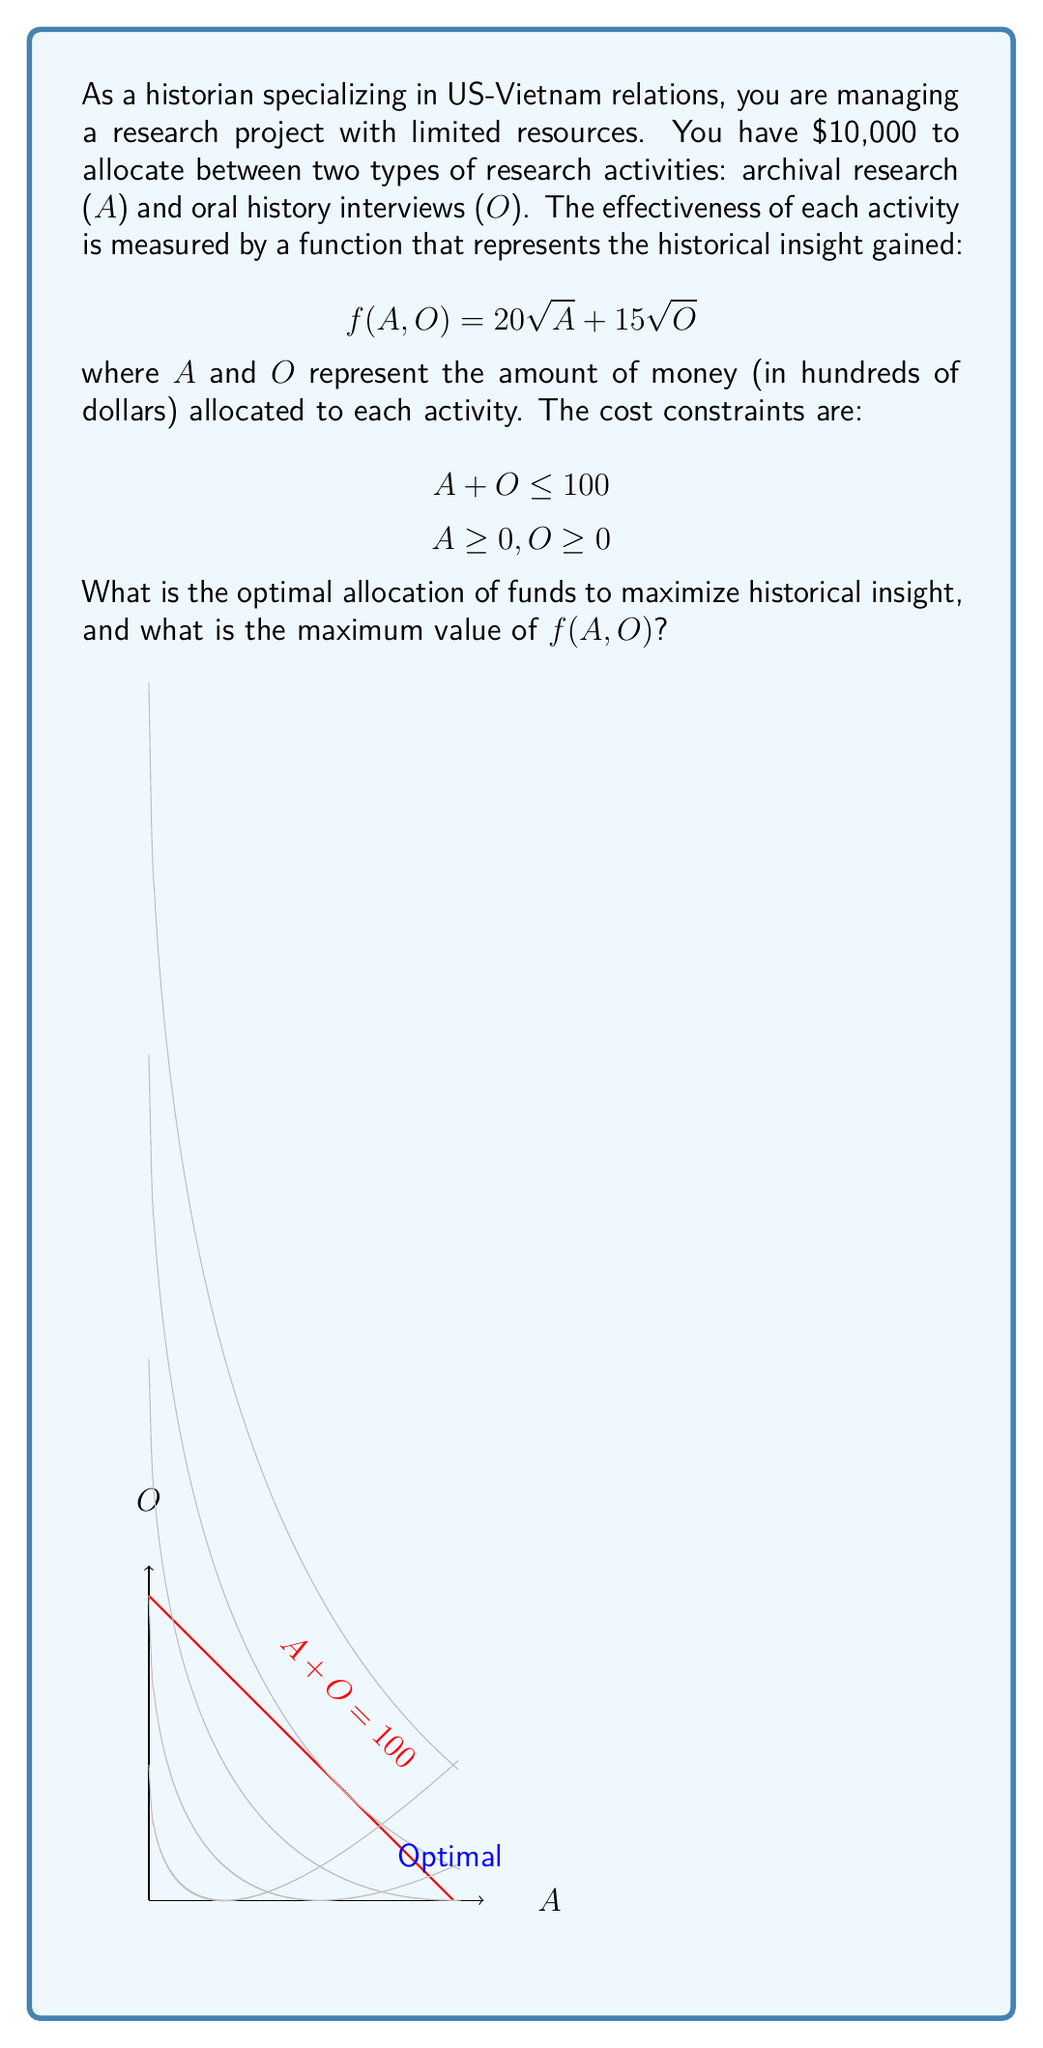Provide a solution to this math problem. To solve this optimization problem, we'll use the method of Lagrange multipliers:

1) Let's define the Lagrangian function:
   $$L(A, O, \lambda) = 20\sqrt{A} + 15\sqrt{O} + \lambda(100 - A - O)$$

2) We find the partial derivatives and set them to zero:
   $$\frac{\partial L}{\partial A} = \frac{10}{\sqrt{A}} - \lambda = 0$$
   $$\frac{\partial L}{\partial O} = \frac{7.5}{\sqrt{O}} - \lambda = 0$$
   $$\frac{\partial L}{\partial \lambda} = 100 - A - O = 0$$

3) From the first two equations:
   $$\frac{10}{\sqrt{A}} = \frac{7.5}{\sqrt{O}}$$

4) Squaring both sides:
   $$\frac{100}{A} = \frac{56.25}{O}$$

5) Cross-multiplying:
   $$100O = 56.25A$$
   $$O = 0.5625A$$

6) Substituting this into the constraint equation:
   $$A + 0.5625A = 100$$
   $$1.5625A = 100$$
   $$A = 64$$

7) Then:
   $$O = 100 - 64 = 36$$

8) The maximum value of f(A, O) is:
   $$f(64, 36) = 20\sqrt{64} + 15\sqrt{36} = 20(8) + 15(6) = 250$$

Therefore, the optimal allocation is $6,400 for archival research and $3,600 for oral history interviews, yielding a maximum historical insight value of 250 units.
Answer: Archival research: $6,400; Oral history: $3,600; Maximum insight: 250 units 